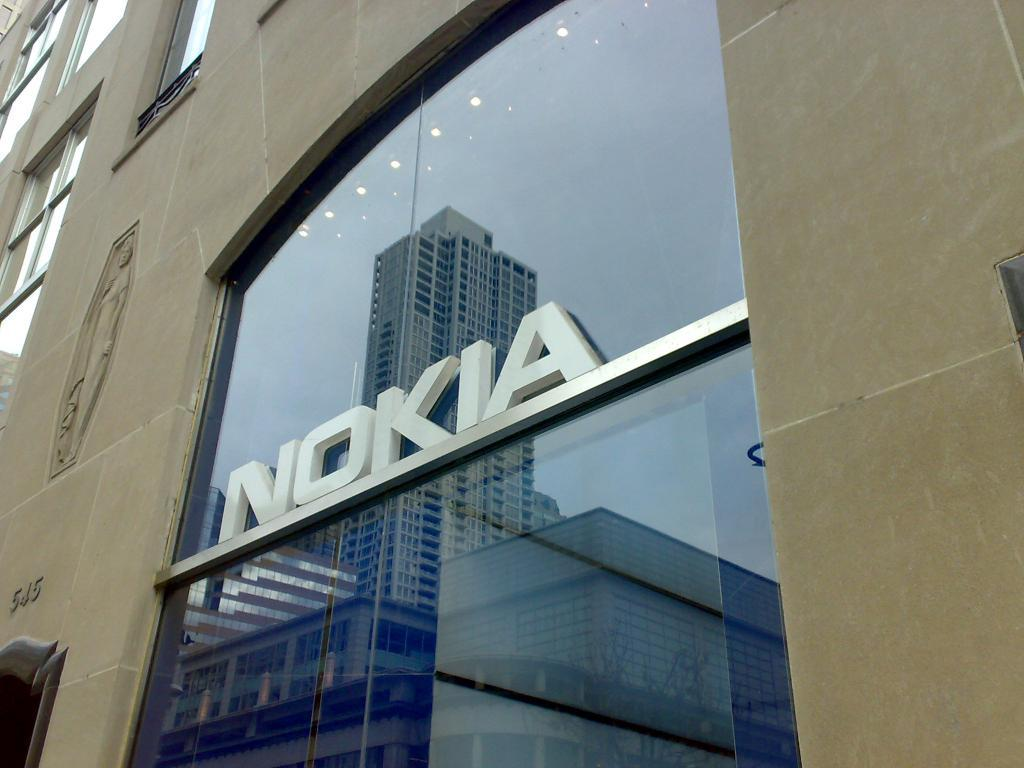What is the main subject of the image? The main subject of the image is a building. What specific features can be observed on the building? The building has windows. What is located in the center of the image? There is text in the center of the image. What can be seen through the windows of the building? Some buildings are visible through the windows in the image. What type of vest can be seen on the person in the image? There is no person or vest present in the image; it features a building with windows and text. What song is playing in the background of the image? There is no audio or song present in the image; it is a static visual representation of a building. 